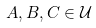<formula> <loc_0><loc_0><loc_500><loc_500>A , B , C \in { \mathcal { U } }</formula> 